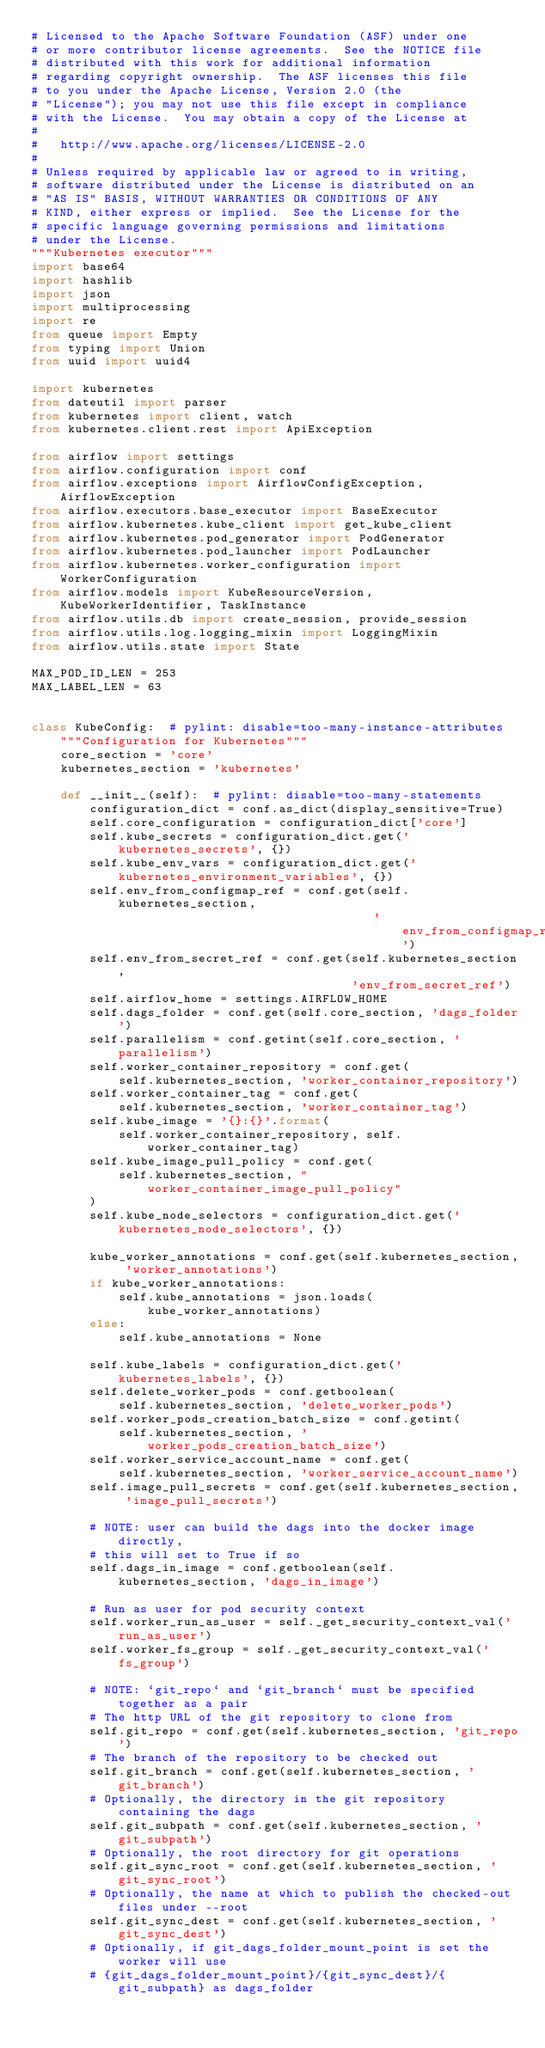Convert code to text. <code><loc_0><loc_0><loc_500><loc_500><_Python_># Licensed to the Apache Software Foundation (ASF) under one
# or more contributor license agreements.  See the NOTICE file
# distributed with this work for additional information
# regarding copyright ownership.  The ASF licenses this file
# to you under the Apache License, Version 2.0 (the
# "License"); you may not use this file except in compliance
# with the License.  You may obtain a copy of the License at
#
#   http://www.apache.org/licenses/LICENSE-2.0
#
# Unless required by applicable law or agreed to in writing,
# software distributed under the License is distributed on an
# "AS IS" BASIS, WITHOUT WARRANTIES OR CONDITIONS OF ANY
# KIND, either express or implied.  See the License for the
# specific language governing permissions and limitations
# under the License.
"""Kubernetes executor"""
import base64
import hashlib
import json
import multiprocessing
import re
from queue import Empty
from typing import Union
from uuid import uuid4

import kubernetes
from dateutil import parser
from kubernetes import client, watch
from kubernetes.client.rest import ApiException

from airflow import settings
from airflow.configuration import conf
from airflow.exceptions import AirflowConfigException, AirflowException
from airflow.executors.base_executor import BaseExecutor
from airflow.kubernetes.kube_client import get_kube_client
from airflow.kubernetes.pod_generator import PodGenerator
from airflow.kubernetes.pod_launcher import PodLauncher
from airflow.kubernetes.worker_configuration import WorkerConfiguration
from airflow.models import KubeResourceVersion, KubeWorkerIdentifier, TaskInstance
from airflow.utils.db import create_session, provide_session
from airflow.utils.log.logging_mixin import LoggingMixin
from airflow.utils.state import State

MAX_POD_ID_LEN = 253
MAX_LABEL_LEN = 63


class KubeConfig:  # pylint: disable=too-many-instance-attributes
    """Configuration for Kubernetes"""
    core_section = 'core'
    kubernetes_section = 'kubernetes'

    def __init__(self):  # pylint: disable=too-many-statements
        configuration_dict = conf.as_dict(display_sensitive=True)
        self.core_configuration = configuration_dict['core']
        self.kube_secrets = configuration_dict.get('kubernetes_secrets', {})
        self.kube_env_vars = configuration_dict.get('kubernetes_environment_variables', {})
        self.env_from_configmap_ref = conf.get(self.kubernetes_section,
                                               'env_from_configmap_ref')
        self.env_from_secret_ref = conf.get(self.kubernetes_section,
                                            'env_from_secret_ref')
        self.airflow_home = settings.AIRFLOW_HOME
        self.dags_folder = conf.get(self.core_section, 'dags_folder')
        self.parallelism = conf.getint(self.core_section, 'parallelism')
        self.worker_container_repository = conf.get(
            self.kubernetes_section, 'worker_container_repository')
        self.worker_container_tag = conf.get(
            self.kubernetes_section, 'worker_container_tag')
        self.kube_image = '{}:{}'.format(
            self.worker_container_repository, self.worker_container_tag)
        self.kube_image_pull_policy = conf.get(
            self.kubernetes_section, "worker_container_image_pull_policy"
        )
        self.kube_node_selectors = configuration_dict.get('kubernetes_node_selectors', {})

        kube_worker_annotations = conf.get(self.kubernetes_section, 'worker_annotations')
        if kube_worker_annotations:
            self.kube_annotations = json.loads(kube_worker_annotations)
        else:
            self.kube_annotations = None

        self.kube_labels = configuration_dict.get('kubernetes_labels', {})
        self.delete_worker_pods = conf.getboolean(
            self.kubernetes_section, 'delete_worker_pods')
        self.worker_pods_creation_batch_size = conf.getint(
            self.kubernetes_section, 'worker_pods_creation_batch_size')
        self.worker_service_account_name = conf.get(
            self.kubernetes_section, 'worker_service_account_name')
        self.image_pull_secrets = conf.get(self.kubernetes_section, 'image_pull_secrets')

        # NOTE: user can build the dags into the docker image directly,
        # this will set to True if so
        self.dags_in_image = conf.getboolean(self.kubernetes_section, 'dags_in_image')

        # Run as user for pod security context
        self.worker_run_as_user = self._get_security_context_val('run_as_user')
        self.worker_fs_group = self._get_security_context_val('fs_group')

        # NOTE: `git_repo` and `git_branch` must be specified together as a pair
        # The http URL of the git repository to clone from
        self.git_repo = conf.get(self.kubernetes_section, 'git_repo')
        # The branch of the repository to be checked out
        self.git_branch = conf.get(self.kubernetes_section, 'git_branch')
        # Optionally, the directory in the git repository containing the dags
        self.git_subpath = conf.get(self.kubernetes_section, 'git_subpath')
        # Optionally, the root directory for git operations
        self.git_sync_root = conf.get(self.kubernetes_section, 'git_sync_root')
        # Optionally, the name at which to publish the checked-out files under --root
        self.git_sync_dest = conf.get(self.kubernetes_section, 'git_sync_dest')
        # Optionally, if git_dags_folder_mount_point is set the worker will use
        # {git_dags_folder_mount_point}/{git_sync_dest}/{git_subpath} as dags_folder</code> 